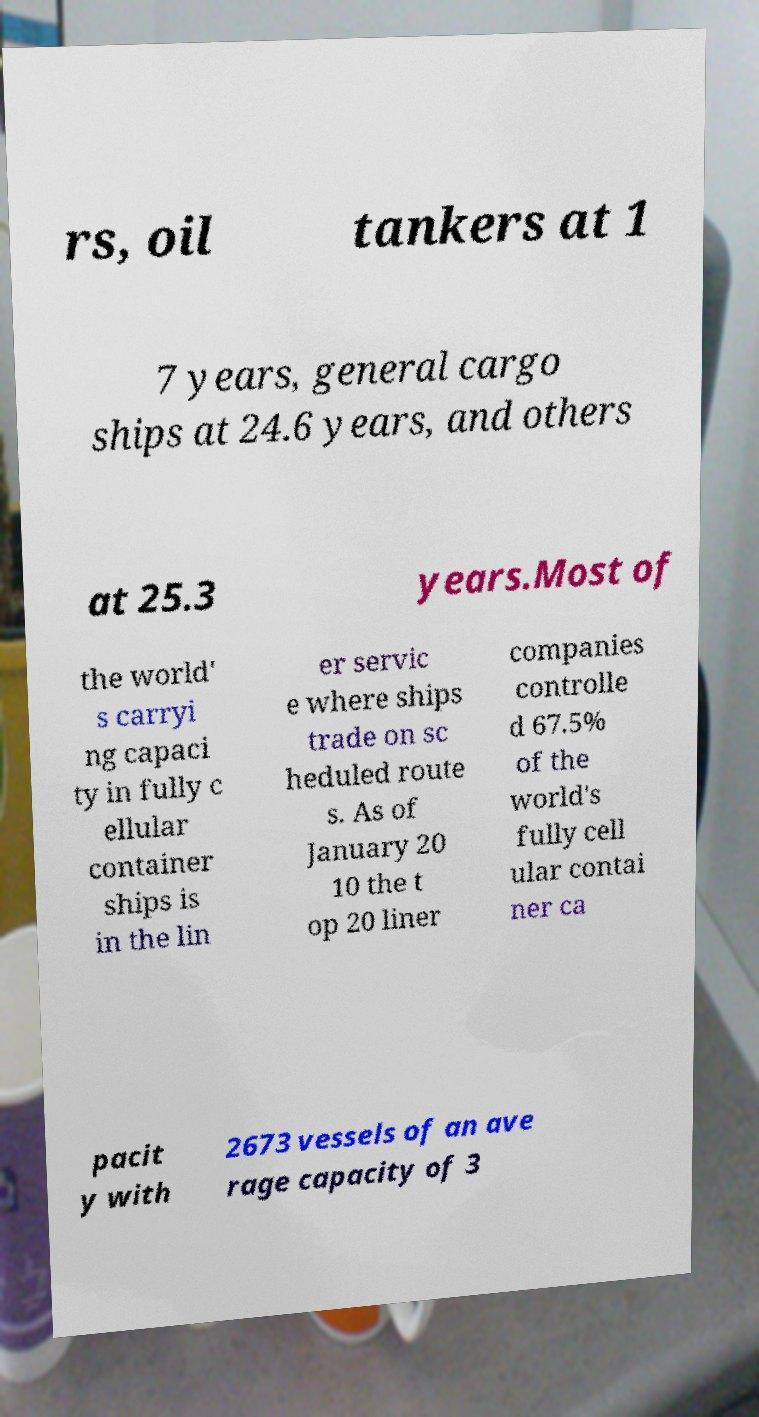Can you read and provide the text displayed in the image?This photo seems to have some interesting text. Can you extract and type it out for me? rs, oil tankers at 1 7 years, general cargo ships at 24.6 years, and others at 25.3 years.Most of the world' s carryi ng capaci ty in fully c ellular container ships is in the lin er servic e where ships trade on sc heduled route s. As of January 20 10 the t op 20 liner companies controlle d 67.5% of the world's fully cell ular contai ner ca pacit y with 2673 vessels of an ave rage capacity of 3 